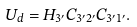Convert formula to latex. <formula><loc_0><loc_0><loc_500><loc_500>U _ { d } = H _ { 3 ^ { \prime } } C _ { 3 ^ { \prime } 2 ^ { \prime } } C _ { 3 ^ { \prime } 1 ^ { \prime } } .</formula> 